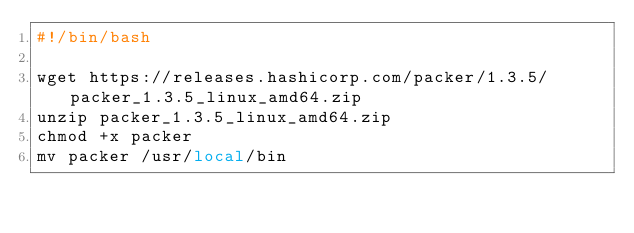Convert code to text. <code><loc_0><loc_0><loc_500><loc_500><_Bash_>#!/bin/bash

wget https://releases.hashicorp.com/packer/1.3.5/packer_1.3.5_linux_amd64.zip
unzip packer_1.3.5_linux_amd64.zip
chmod +x packer
mv packer /usr/local/bin</code> 